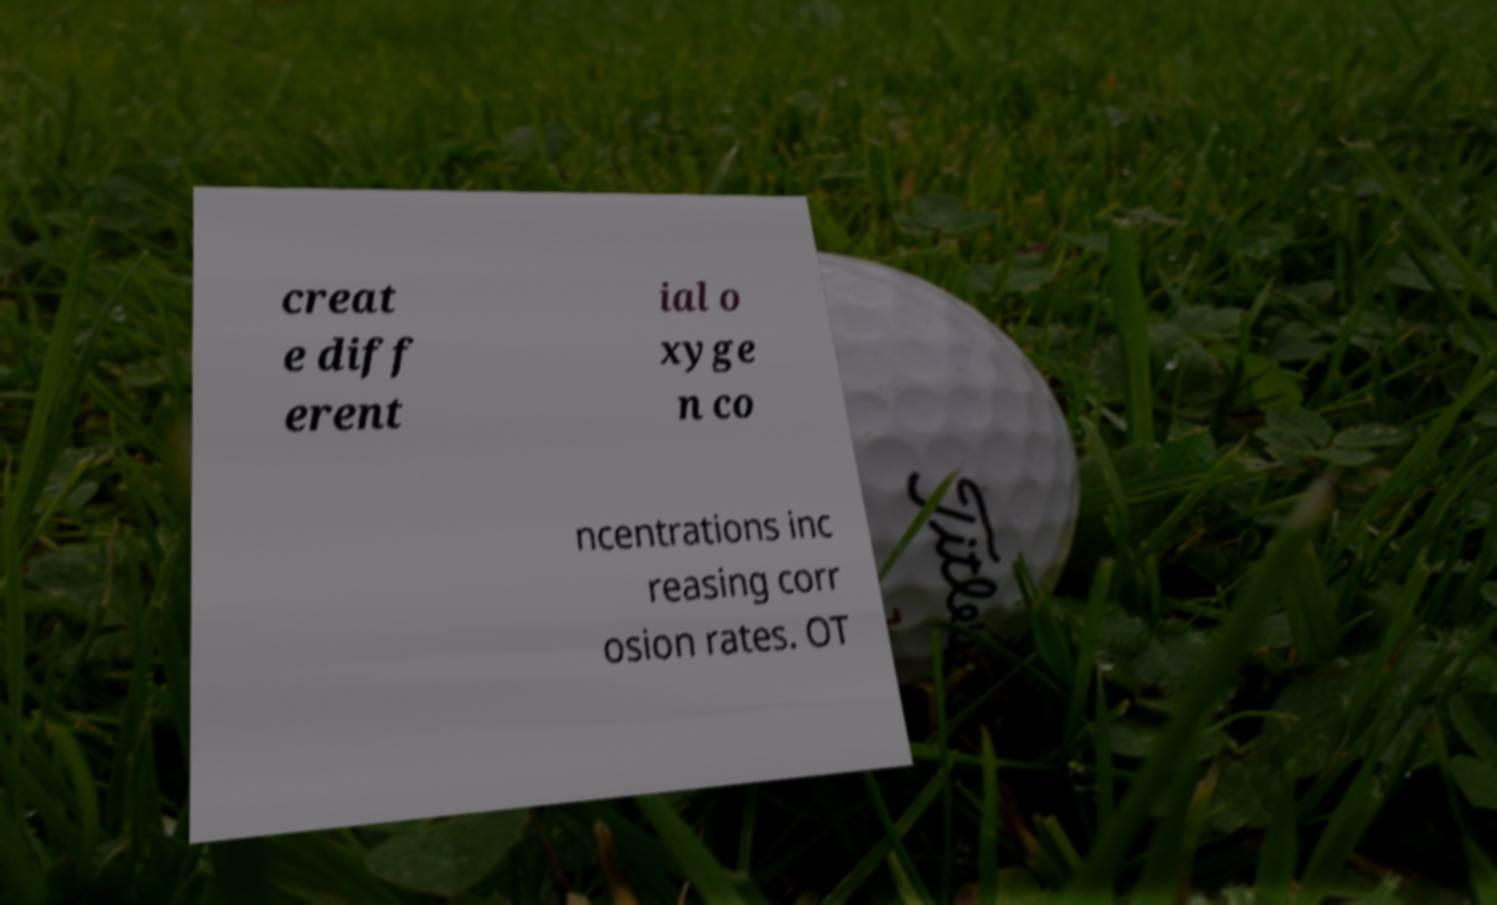Can you read and provide the text displayed in the image?This photo seems to have some interesting text. Can you extract and type it out for me? creat e diff erent ial o xyge n co ncentrations inc reasing corr osion rates. OT 